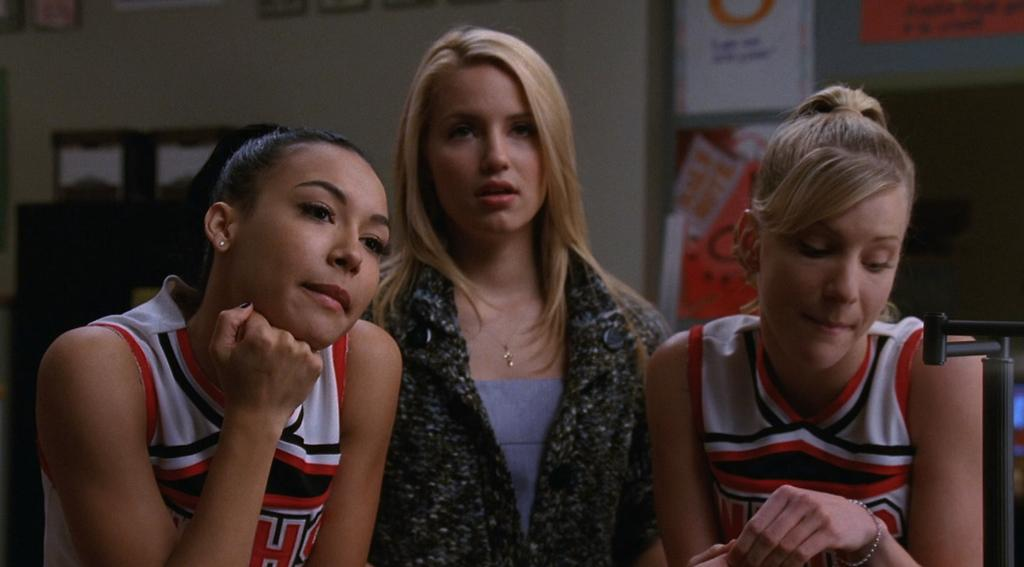<image>
Present a compact description of the photo's key features. The cheerleader on the left has the letter H on her uniform. 